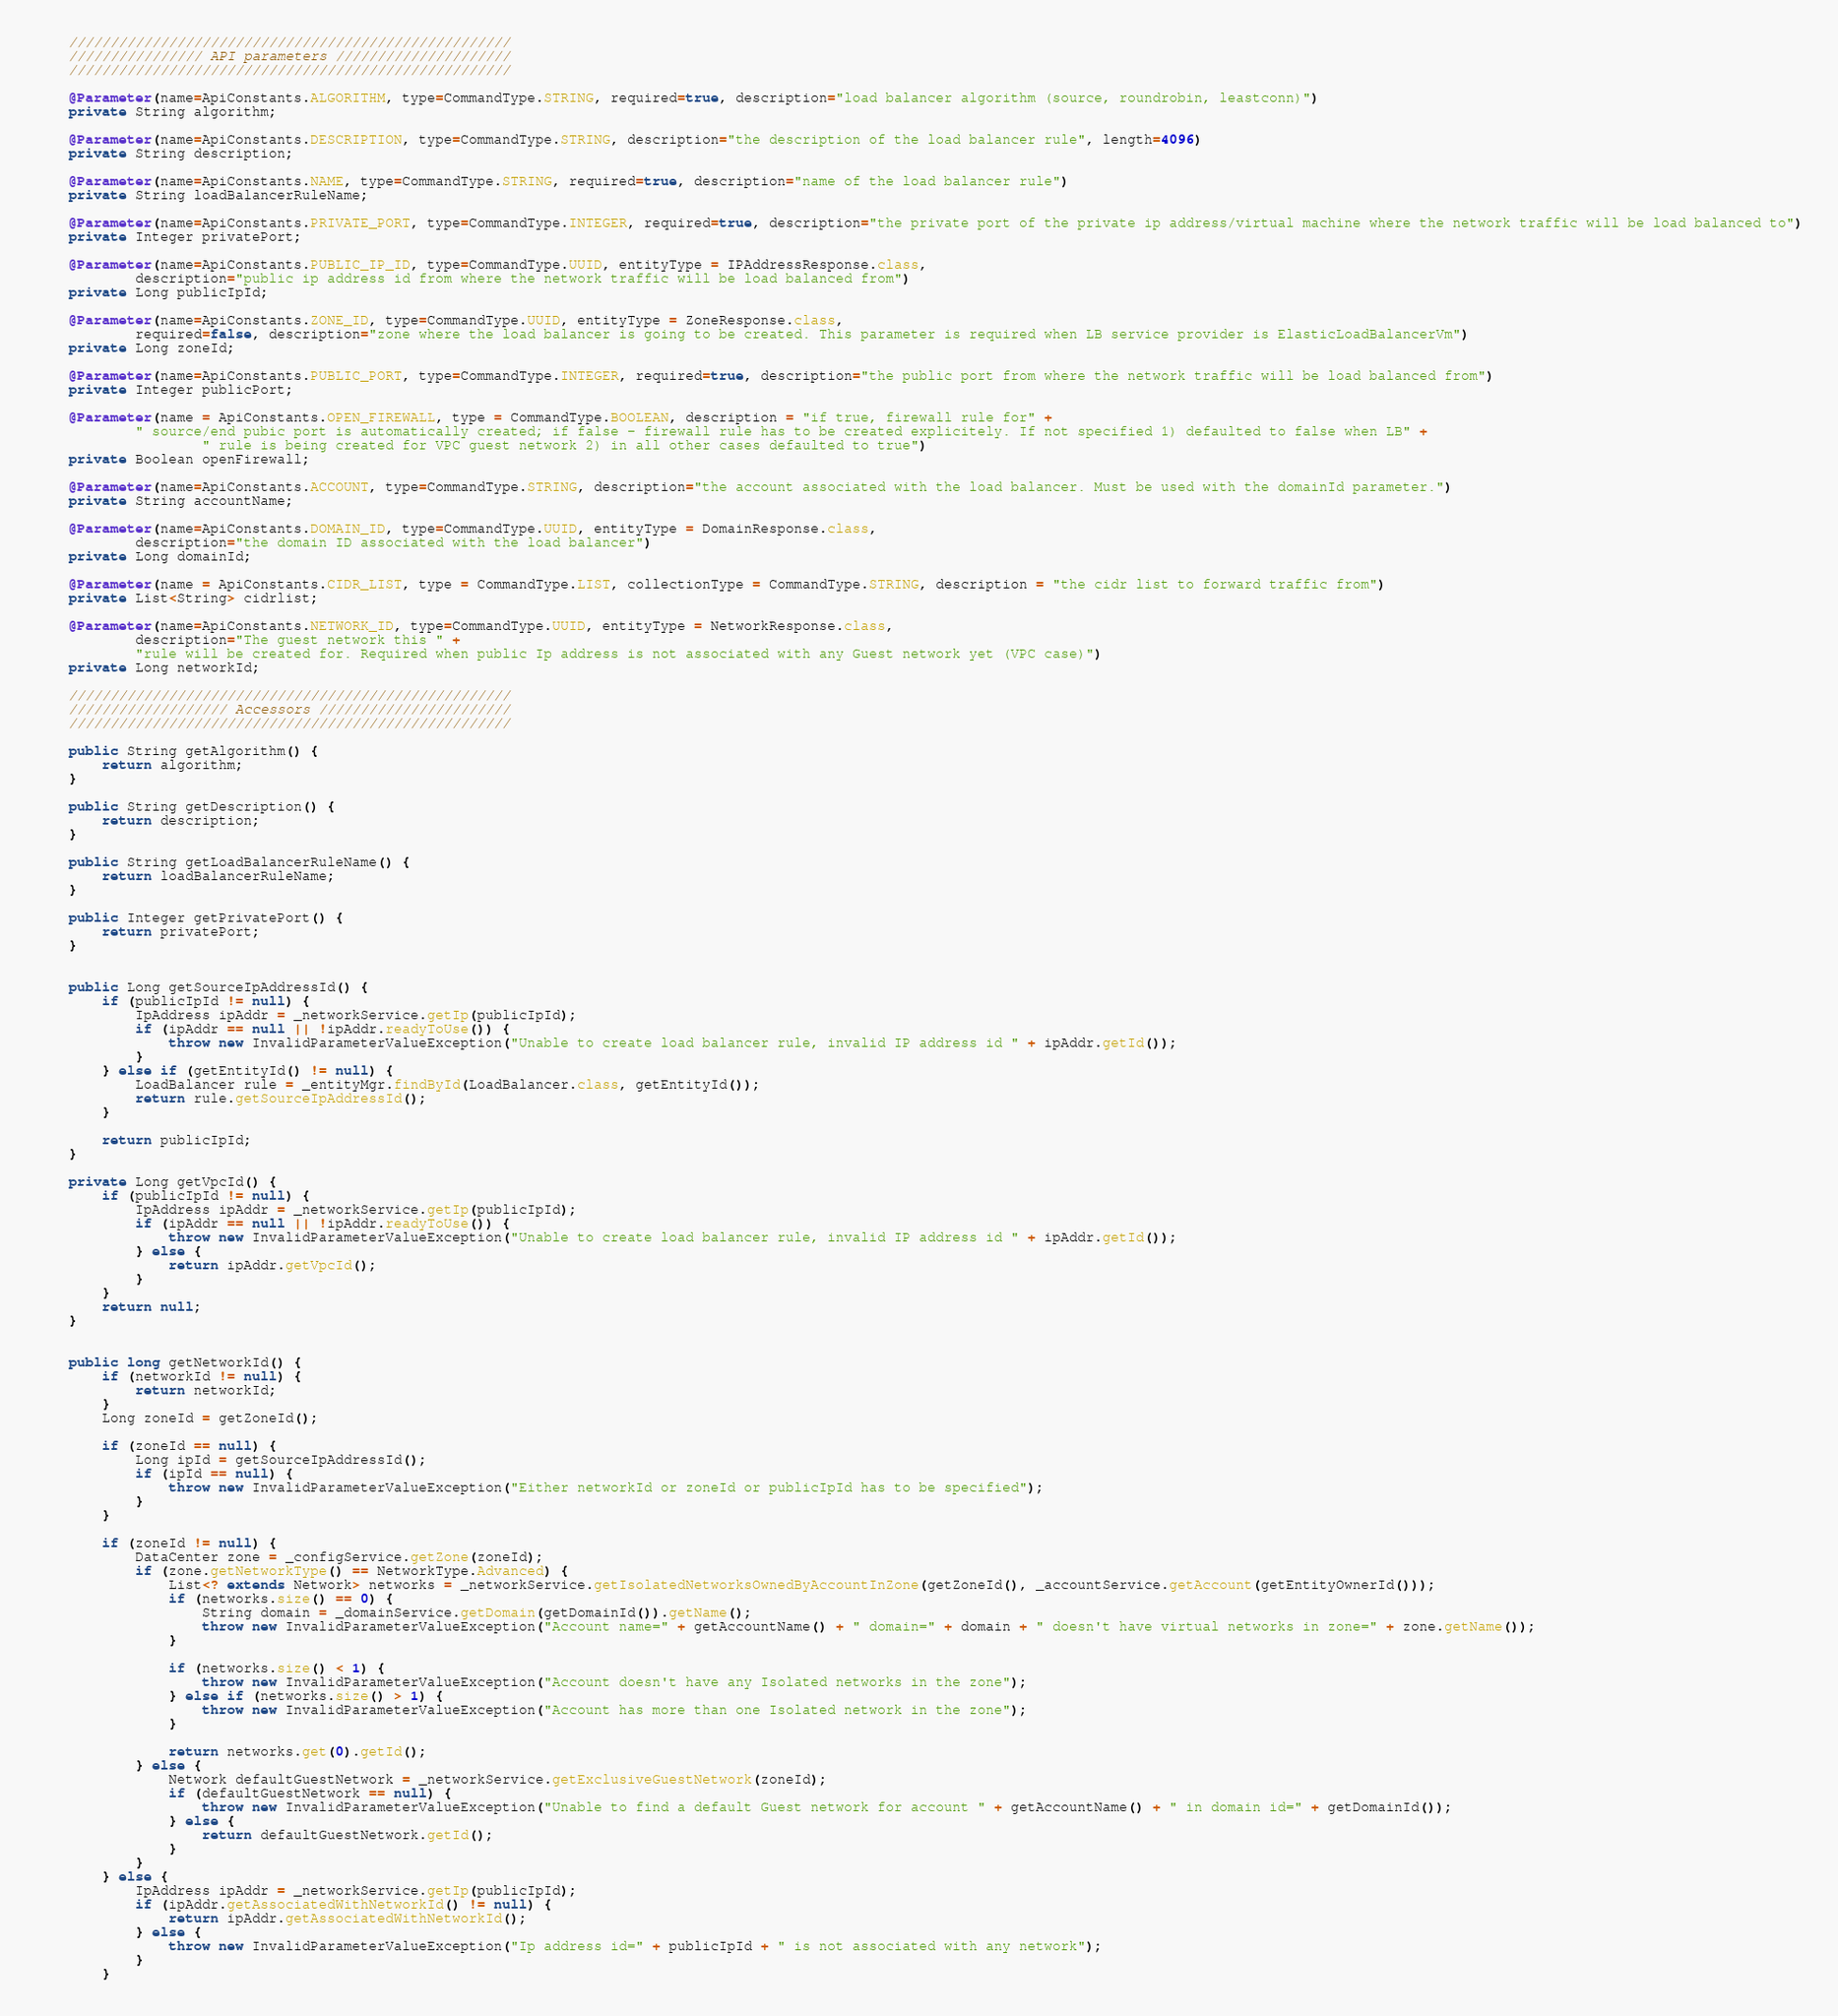<code> <loc_0><loc_0><loc_500><loc_500><_Java_>    /////////////////////////////////////////////////////
    //////////////// API parameters /////////////////////
    /////////////////////////////////////////////////////

    @Parameter(name=ApiConstants.ALGORITHM, type=CommandType.STRING, required=true, description="load balancer algorithm (source, roundrobin, leastconn)")
    private String algorithm;

    @Parameter(name=ApiConstants.DESCRIPTION, type=CommandType.STRING, description="the description of the load balancer rule", length=4096)
    private String description;

    @Parameter(name=ApiConstants.NAME, type=CommandType.STRING, required=true, description="name of the load balancer rule")
    private String loadBalancerRuleName;

    @Parameter(name=ApiConstants.PRIVATE_PORT, type=CommandType.INTEGER, required=true, description="the private port of the private ip address/virtual machine where the network traffic will be load balanced to")
    private Integer privatePort;

    @Parameter(name=ApiConstants.PUBLIC_IP_ID, type=CommandType.UUID, entityType = IPAddressResponse.class,
            description="public ip address id from where the network traffic will be load balanced from")
    private Long publicIpId;

    @Parameter(name=ApiConstants.ZONE_ID, type=CommandType.UUID, entityType = ZoneResponse.class,
            required=false, description="zone where the load balancer is going to be created. This parameter is required when LB service provider is ElasticLoadBalancerVm")
    private Long zoneId;

    @Parameter(name=ApiConstants.PUBLIC_PORT, type=CommandType.INTEGER, required=true, description="the public port from where the network traffic will be load balanced from")
    private Integer publicPort;

    @Parameter(name = ApiConstants.OPEN_FIREWALL, type = CommandType.BOOLEAN, description = "if true, firewall rule for" +
            " source/end pubic port is automatically created; if false - firewall rule has to be created explicitely. If not specified 1) defaulted to false when LB" +
                    " rule is being created for VPC guest network 2) in all other cases defaulted to true")
    private Boolean openFirewall;

    @Parameter(name=ApiConstants.ACCOUNT, type=CommandType.STRING, description="the account associated with the load balancer. Must be used with the domainId parameter.")
    private String accountName;

    @Parameter(name=ApiConstants.DOMAIN_ID, type=CommandType.UUID, entityType = DomainResponse.class,
            description="the domain ID associated with the load balancer")
    private Long domainId;

    @Parameter(name = ApiConstants.CIDR_LIST, type = CommandType.LIST, collectionType = CommandType.STRING, description = "the cidr list to forward traffic from")
    private List<String> cidrlist;

    @Parameter(name=ApiConstants.NETWORK_ID, type=CommandType.UUID, entityType = NetworkResponse.class,
            description="The guest network this " +
            "rule will be created for. Required when public Ip address is not associated with any Guest network yet (VPC case)")
    private Long networkId;

    /////////////////////////////////////////////////////
    /////////////////// Accessors ///////////////////////
    /////////////////////////////////////////////////////

    public String getAlgorithm() {
        return algorithm;
    }

    public String getDescription() {
        return description;
    }

    public String getLoadBalancerRuleName() {
        return loadBalancerRuleName;
    }

    public Integer getPrivatePort() {
        return privatePort;
    }


    public Long getSourceIpAddressId() {
        if (publicIpId != null) {
            IpAddress ipAddr = _networkService.getIp(publicIpId);
            if (ipAddr == null || !ipAddr.readyToUse()) {
                throw new InvalidParameterValueException("Unable to create load balancer rule, invalid IP address id " + ipAddr.getId());
            }
        } else if (getEntityId() != null) {
            LoadBalancer rule = _entityMgr.findById(LoadBalancer.class, getEntityId());
            return rule.getSourceIpAddressId();
        }

        return publicIpId;
    }

    private Long getVpcId() {
        if (publicIpId != null) {
            IpAddress ipAddr = _networkService.getIp(publicIpId);
            if (ipAddr == null || !ipAddr.readyToUse()) {
                throw new InvalidParameterValueException("Unable to create load balancer rule, invalid IP address id " + ipAddr.getId());
            } else {
                return ipAddr.getVpcId();
            }
        }
        return null;
    }


    public long getNetworkId() {
        if (networkId != null) {
            return networkId;
        }
        Long zoneId = getZoneId();

        if (zoneId == null) {
            Long ipId = getSourceIpAddressId();
            if (ipId == null) {
                throw new InvalidParameterValueException("Either networkId or zoneId or publicIpId has to be specified");
            }
        }

        if (zoneId != null) {
            DataCenter zone = _configService.getZone(zoneId);
            if (zone.getNetworkType() == NetworkType.Advanced) {
                List<? extends Network> networks = _networkService.getIsolatedNetworksOwnedByAccountInZone(getZoneId(), _accountService.getAccount(getEntityOwnerId()));
                if (networks.size() == 0) {
                    String domain = _domainService.getDomain(getDomainId()).getName();
                    throw new InvalidParameterValueException("Account name=" + getAccountName() + " domain=" + domain + " doesn't have virtual networks in zone=" + zone.getName());
                }

                if (networks.size() < 1) {
                    throw new InvalidParameterValueException("Account doesn't have any Isolated networks in the zone");
                } else if (networks.size() > 1) {
                    throw new InvalidParameterValueException("Account has more than one Isolated network in the zone");
                }

                return networks.get(0).getId();
            } else {
                Network defaultGuestNetwork = _networkService.getExclusiveGuestNetwork(zoneId);
                if (defaultGuestNetwork == null) {
                    throw new InvalidParameterValueException("Unable to find a default Guest network for account " + getAccountName() + " in domain id=" + getDomainId());
                } else {
                    return defaultGuestNetwork.getId();
                }
            }
        } else {
            IpAddress ipAddr = _networkService.getIp(publicIpId);
            if (ipAddr.getAssociatedWithNetworkId() != null) {
                return ipAddr.getAssociatedWithNetworkId();
            } else {
                throw new InvalidParameterValueException("Ip address id=" + publicIpId + " is not associated with any network");
            }
        }</code> 